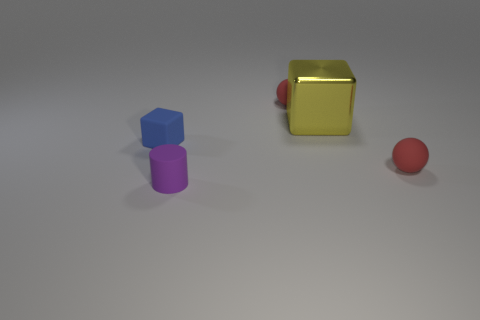Add 2 tiny balls. How many objects exist? 7 Subtract all cylinders. How many objects are left? 4 Add 4 blue things. How many blue things exist? 5 Subtract 0 brown cylinders. How many objects are left? 5 Subtract all blue shiny things. Subtract all yellow metallic cubes. How many objects are left? 4 Add 3 small matte blocks. How many small matte blocks are left? 4 